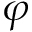<formula> <loc_0><loc_0><loc_500><loc_500>\varphi</formula> 